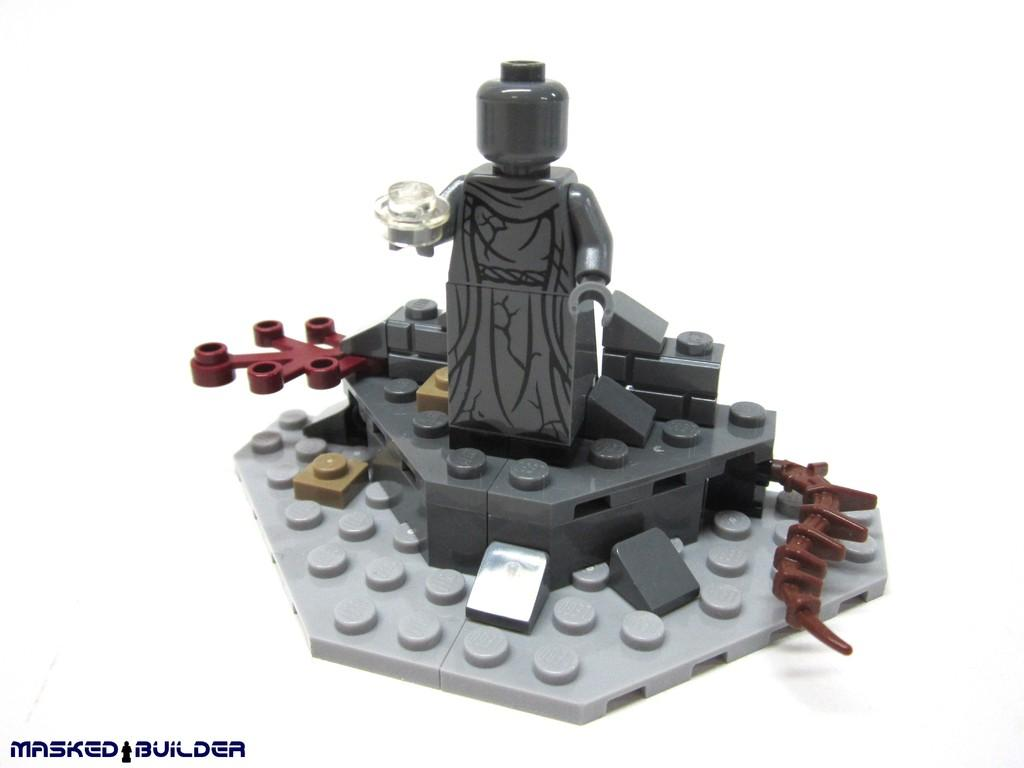What can be seen in the image besides the background? There is a toy in the image. What color is the background of the image? The background of the image is white. Where is the text located in the image? The text is in the left bottom corner of the image. What type of tray is used to hold the toy in the image? There is no tray present in the image; the toy is not on a tray. What is the title of the toy in the image? The image does not have a title for the toy, as it is not a photograph or illustration of a specific toy with a name. 